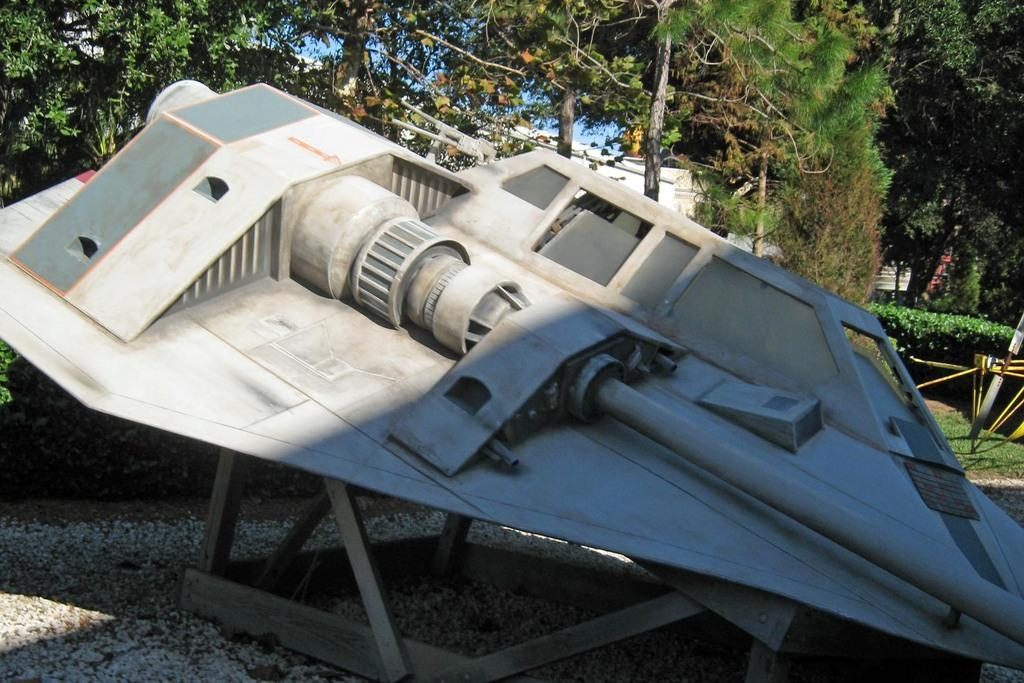What is the main subject in the center of the image? There is a depiction of an aircraft in the center of the image. What can be seen in the background of the image? There are trees in the background of the image. What type of objects are at the bottom of the image? There are stones at the bottom of the image. Can you see a donkey carrying a net in the image? No, there is no donkey or net present in the image. 